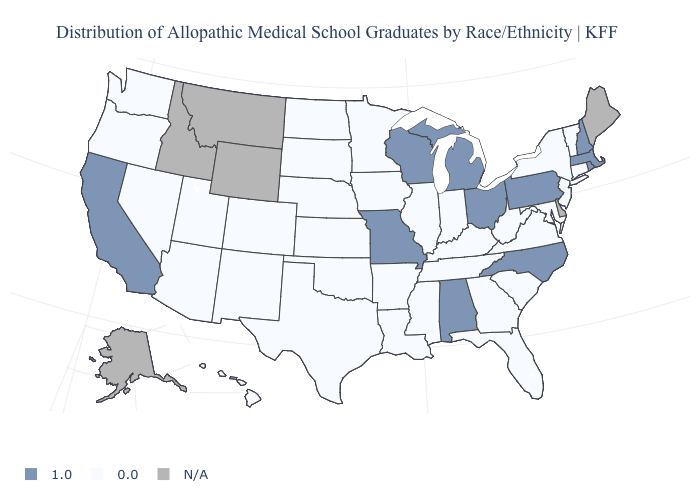Name the states that have a value in the range N/A?
Answer briefly. Alaska, Delaware, Idaho, Maine, Montana, Wyoming. What is the value of Oregon?
Quick response, please. 0.0. Does the map have missing data?
Concise answer only. Yes. What is the value of Massachusetts?
Give a very brief answer. 1.0. Does North Carolina have the highest value in the USA?
Be succinct. Yes. Does Massachusetts have the lowest value in the Northeast?
Be succinct. No. Which states have the lowest value in the USA?
Give a very brief answer. Arizona, Arkansas, Colorado, Connecticut, Florida, Georgia, Hawaii, Illinois, Indiana, Iowa, Kansas, Kentucky, Louisiana, Maryland, Minnesota, Mississippi, Nebraska, Nevada, New Jersey, New Mexico, New York, North Dakota, Oklahoma, Oregon, South Carolina, South Dakota, Tennessee, Texas, Utah, Vermont, Virginia, Washington, West Virginia. What is the lowest value in states that border South Dakota?
Quick response, please. 0.0. Does Pennsylvania have the lowest value in the USA?
Write a very short answer. No. Is the legend a continuous bar?
Concise answer only. No. Name the states that have a value in the range 1.0?
Quick response, please. Alabama, California, Massachusetts, Michigan, Missouri, New Hampshire, North Carolina, Ohio, Pennsylvania, Rhode Island, Wisconsin. Among the states that border Mississippi , which have the highest value?
Write a very short answer. Alabama. What is the value of West Virginia?
Short answer required. 0.0. Does the map have missing data?
Quick response, please. Yes. 